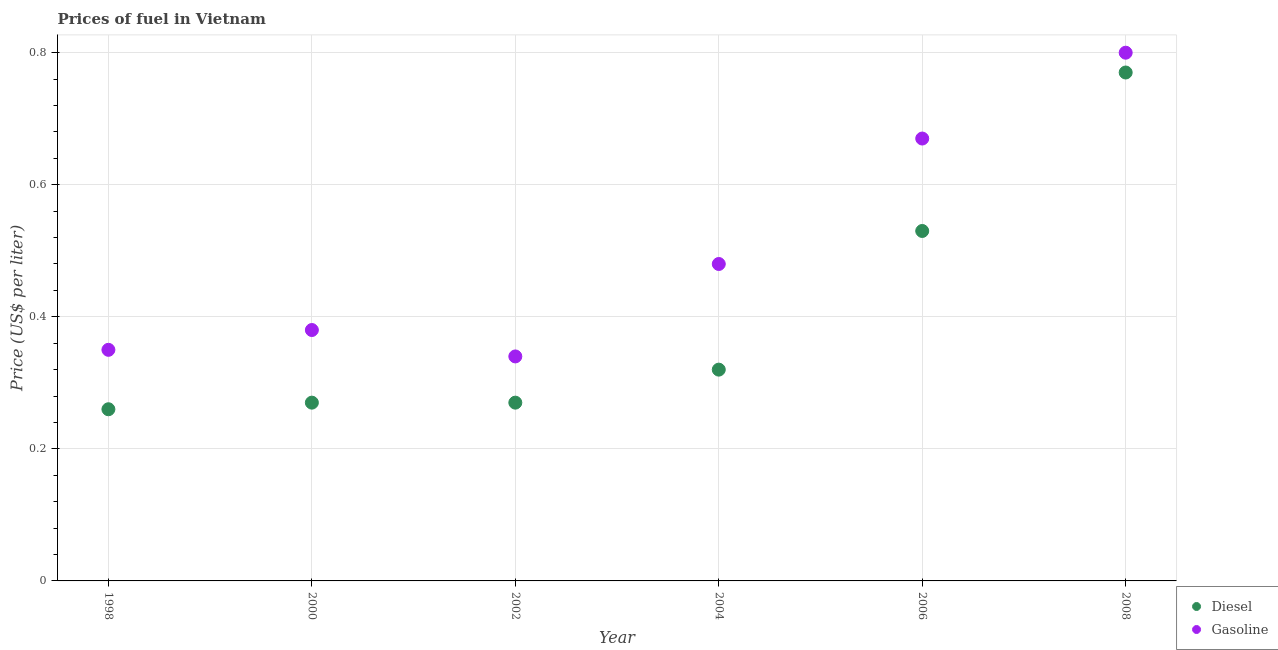Is the number of dotlines equal to the number of legend labels?
Your response must be concise. Yes. What is the diesel price in 2006?
Your answer should be compact. 0.53. Across all years, what is the maximum gasoline price?
Your answer should be compact. 0.8. Across all years, what is the minimum diesel price?
Provide a short and direct response. 0.26. In which year was the gasoline price maximum?
Give a very brief answer. 2008. In which year was the diesel price minimum?
Give a very brief answer. 1998. What is the total gasoline price in the graph?
Provide a short and direct response. 3.02. What is the difference between the gasoline price in 2000 and that in 2002?
Ensure brevity in your answer.  0.04. What is the difference between the gasoline price in 2004 and the diesel price in 2008?
Give a very brief answer. -0.29. What is the average gasoline price per year?
Offer a terse response. 0.5. In the year 2006, what is the difference between the diesel price and gasoline price?
Make the answer very short. -0.14. What is the ratio of the diesel price in 2002 to that in 2004?
Provide a short and direct response. 0.84. Is the difference between the diesel price in 2000 and 2008 greater than the difference between the gasoline price in 2000 and 2008?
Provide a short and direct response. No. What is the difference between the highest and the second highest gasoline price?
Make the answer very short. 0.13. What is the difference between the highest and the lowest gasoline price?
Provide a succinct answer. 0.46. Is the diesel price strictly greater than the gasoline price over the years?
Provide a succinct answer. No. Is the diesel price strictly less than the gasoline price over the years?
Give a very brief answer. Yes. How many dotlines are there?
Offer a terse response. 2. How many years are there in the graph?
Offer a terse response. 6. What is the difference between two consecutive major ticks on the Y-axis?
Your answer should be compact. 0.2. Does the graph contain grids?
Offer a very short reply. Yes. How are the legend labels stacked?
Your answer should be compact. Vertical. What is the title of the graph?
Provide a succinct answer. Prices of fuel in Vietnam. What is the label or title of the X-axis?
Your response must be concise. Year. What is the label or title of the Y-axis?
Give a very brief answer. Price (US$ per liter). What is the Price (US$ per liter) of Diesel in 1998?
Your answer should be very brief. 0.26. What is the Price (US$ per liter) in Gasoline in 1998?
Give a very brief answer. 0.35. What is the Price (US$ per liter) in Diesel in 2000?
Ensure brevity in your answer.  0.27. What is the Price (US$ per liter) of Gasoline in 2000?
Your answer should be compact. 0.38. What is the Price (US$ per liter) of Diesel in 2002?
Your response must be concise. 0.27. What is the Price (US$ per liter) of Gasoline in 2002?
Offer a terse response. 0.34. What is the Price (US$ per liter) in Diesel in 2004?
Ensure brevity in your answer.  0.32. What is the Price (US$ per liter) in Gasoline in 2004?
Ensure brevity in your answer.  0.48. What is the Price (US$ per liter) in Diesel in 2006?
Provide a succinct answer. 0.53. What is the Price (US$ per liter) in Gasoline in 2006?
Provide a short and direct response. 0.67. What is the Price (US$ per liter) in Diesel in 2008?
Offer a very short reply. 0.77. What is the Price (US$ per liter) of Gasoline in 2008?
Provide a short and direct response. 0.8. Across all years, what is the maximum Price (US$ per liter) in Diesel?
Your response must be concise. 0.77. Across all years, what is the maximum Price (US$ per liter) of Gasoline?
Your answer should be compact. 0.8. Across all years, what is the minimum Price (US$ per liter) of Diesel?
Your answer should be compact. 0.26. Across all years, what is the minimum Price (US$ per liter) of Gasoline?
Offer a very short reply. 0.34. What is the total Price (US$ per liter) in Diesel in the graph?
Ensure brevity in your answer.  2.42. What is the total Price (US$ per liter) of Gasoline in the graph?
Make the answer very short. 3.02. What is the difference between the Price (US$ per liter) in Diesel in 1998 and that in 2000?
Keep it short and to the point. -0.01. What is the difference between the Price (US$ per liter) in Gasoline in 1998 and that in 2000?
Keep it short and to the point. -0.03. What is the difference between the Price (US$ per liter) of Diesel in 1998 and that in 2002?
Your answer should be very brief. -0.01. What is the difference between the Price (US$ per liter) of Gasoline in 1998 and that in 2002?
Your answer should be very brief. 0.01. What is the difference between the Price (US$ per liter) in Diesel in 1998 and that in 2004?
Provide a succinct answer. -0.06. What is the difference between the Price (US$ per liter) of Gasoline in 1998 and that in 2004?
Your response must be concise. -0.13. What is the difference between the Price (US$ per liter) of Diesel in 1998 and that in 2006?
Your answer should be very brief. -0.27. What is the difference between the Price (US$ per liter) of Gasoline in 1998 and that in 2006?
Keep it short and to the point. -0.32. What is the difference between the Price (US$ per liter) in Diesel in 1998 and that in 2008?
Offer a terse response. -0.51. What is the difference between the Price (US$ per liter) of Gasoline in 1998 and that in 2008?
Provide a short and direct response. -0.45. What is the difference between the Price (US$ per liter) in Gasoline in 2000 and that in 2002?
Give a very brief answer. 0.04. What is the difference between the Price (US$ per liter) in Gasoline in 2000 and that in 2004?
Offer a terse response. -0.1. What is the difference between the Price (US$ per liter) of Diesel in 2000 and that in 2006?
Your answer should be very brief. -0.26. What is the difference between the Price (US$ per liter) of Gasoline in 2000 and that in 2006?
Ensure brevity in your answer.  -0.29. What is the difference between the Price (US$ per liter) of Diesel in 2000 and that in 2008?
Make the answer very short. -0.5. What is the difference between the Price (US$ per liter) in Gasoline in 2000 and that in 2008?
Your answer should be compact. -0.42. What is the difference between the Price (US$ per liter) of Diesel in 2002 and that in 2004?
Make the answer very short. -0.05. What is the difference between the Price (US$ per liter) of Gasoline in 2002 and that in 2004?
Ensure brevity in your answer.  -0.14. What is the difference between the Price (US$ per liter) in Diesel in 2002 and that in 2006?
Ensure brevity in your answer.  -0.26. What is the difference between the Price (US$ per liter) of Gasoline in 2002 and that in 2006?
Provide a succinct answer. -0.33. What is the difference between the Price (US$ per liter) of Diesel in 2002 and that in 2008?
Provide a succinct answer. -0.5. What is the difference between the Price (US$ per liter) of Gasoline in 2002 and that in 2008?
Keep it short and to the point. -0.46. What is the difference between the Price (US$ per liter) of Diesel in 2004 and that in 2006?
Make the answer very short. -0.21. What is the difference between the Price (US$ per liter) of Gasoline in 2004 and that in 2006?
Your response must be concise. -0.19. What is the difference between the Price (US$ per liter) in Diesel in 2004 and that in 2008?
Ensure brevity in your answer.  -0.45. What is the difference between the Price (US$ per liter) of Gasoline in 2004 and that in 2008?
Provide a short and direct response. -0.32. What is the difference between the Price (US$ per liter) in Diesel in 2006 and that in 2008?
Keep it short and to the point. -0.24. What is the difference between the Price (US$ per liter) of Gasoline in 2006 and that in 2008?
Your answer should be very brief. -0.13. What is the difference between the Price (US$ per liter) in Diesel in 1998 and the Price (US$ per liter) in Gasoline in 2000?
Provide a succinct answer. -0.12. What is the difference between the Price (US$ per liter) of Diesel in 1998 and the Price (US$ per liter) of Gasoline in 2002?
Keep it short and to the point. -0.08. What is the difference between the Price (US$ per liter) in Diesel in 1998 and the Price (US$ per liter) in Gasoline in 2004?
Make the answer very short. -0.22. What is the difference between the Price (US$ per liter) of Diesel in 1998 and the Price (US$ per liter) of Gasoline in 2006?
Your answer should be compact. -0.41. What is the difference between the Price (US$ per liter) in Diesel in 1998 and the Price (US$ per liter) in Gasoline in 2008?
Ensure brevity in your answer.  -0.54. What is the difference between the Price (US$ per liter) in Diesel in 2000 and the Price (US$ per liter) in Gasoline in 2002?
Your answer should be very brief. -0.07. What is the difference between the Price (US$ per liter) of Diesel in 2000 and the Price (US$ per liter) of Gasoline in 2004?
Provide a short and direct response. -0.21. What is the difference between the Price (US$ per liter) in Diesel in 2000 and the Price (US$ per liter) in Gasoline in 2006?
Provide a short and direct response. -0.4. What is the difference between the Price (US$ per liter) of Diesel in 2000 and the Price (US$ per liter) of Gasoline in 2008?
Provide a succinct answer. -0.53. What is the difference between the Price (US$ per liter) in Diesel in 2002 and the Price (US$ per liter) in Gasoline in 2004?
Provide a succinct answer. -0.21. What is the difference between the Price (US$ per liter) of Diesel in 2002 and the Price (US$ per liter) of Gasoline in 2008?
Your answer should be compact. -0.53. What is the difference between the Price (US$ per liter) of Diesel in 2004 and the Price (US$ per liter) of Gasoline in 2006?
Provide a succinct answer. -0.35. What is the difference between the Price (US$ per liter) in Diesel in 2004 and the Price (US$ per liter) in Gasoline in 2008?
Ensure brevity in your answer.  -0.48. What is the difference between the Price (US$ per liter) of Diesel in 2006 and the Price (US$ per liter) of Gasoline in 2008?
Your response must be concise. -0.27. What is the average Price (US$ per liter) in Diesel per year?
Give a very brief answer. 0.4. What is the average Price (US$ per liter) in Gasoline per year?
Offer a terse response. 0.5. In the year 1998, what is the difference between the Price (US$ per liter) in Diesel and Price (US$ per liter) in Gasoline?
Provide a succinct answer. -0.09. In the year 2000, what is the difference between the Price (US$ per liter) in Diesel and Price (US$ per liter) in Gasoline?
Provide a succinct answer. -0.11. In the year 2002, what is the difference between the Price (US$ per liter) of Diesel and Price (US$ per liter) of Gasoline?
Offer a very short reply. -0.07. In the year 2004, what is the difference between the Price (US$ per liter) in Diesel and Price (US$ per liter) in Gasoline?
Provide a succinct answer. -0.16. In the year 2006, what is the difference between the Price (US$ per liter) in Diesel and Price (US$ per liter) in Gasoline?
Offer a very short reply. -0.14. In the year 2008, what is the difference between the Price (US$ per liter) of Diesel and Price (US$ per liter) of Gasoline?
Provide a succinct answer. -0.03. What is the ratio of the Price (US$ per liter) in Diesel in 1998 to that in 2000?
Your answer should be compact. 0.96. What is the ratio of the Price (US$ per liter) in Gasoline in 1998 to that in 2000?
Provide a succinct answer. 0.92. What is the ratio of the Price (US$ per liter) in Gasoline in 1998 to that in 2002?
Ensure brevity in your answer.  1.03. What is the ratio of the Price (US$ per liter) of Diesel in 1998 to that in 2004?
Provide a succinct answer. 0.81. What is the ratio of the Price (US$ per liter) in Gasoline in 1998 to that in 2004?
Keep it short and to the point. 0.73. What is the ratio of the Price (US$ per liter) in Diesel in 1998 to that in 2006?
Offer a terse response. 0.49. What is the ratio of the Price (US$ per liter) of Gasoline in 1998 to that in 2006?
Make the answer very short. 0.52. What is the ratio of the Price (US$ per liter) of Diesel in 1998 to that in 2008?
Offer a terse response. 0.34. What is the ratio of the Price (US$ per liter) in Gasoline in 1998 to that in 2008?
Offer a terse response. 0.44. What is the ratio of the Price (US$ per liter) of Diesel in 2000 to that in 2002?
Your answer should be very brief. 1. What is the ratio of the Price (US$ per liter) in Gasoline in 2000 to that in 2002?
Your answer should be very brief. 1.12. What is the ratio of the Price (US$ per liter) in Diesel in 2000 to that in 2004?
Keep it short and to the point. 0.84. What is the ratio of the Price (US$ per liter) in Gasoline in 2000 to that in 2004?
Your response must be concise. 0.79. What is the ratio of the Price (US$ per liter) of Diesel in 2000 to that in 2006?
Ensure brevity in your answer.  0.51. What is the ratio of the Price (US$ per liter) of Gasoline in 2000 to that in 2006?
Offer a very short reply. 0.57. What is the ratio of the Price (US$ per liter) in Diesel in 2000 to that in 2008?
Give a very brief answer. 0.35. What is the ratio of the Price (US$ per liter) in Gasoline in 2000 to that in 2008?
Your response must be concise. 0.47. What is the ratio of the Price (US$ per liter) in Diesel in 2002 to that in 2004?
Ensure brevity in your answer.  0.84. What is the ratio of the Price (US$ per liter) in Gasoline in 2002 to that in 2004?
Give a very brief answer. 0.71. What is the ratio of the Price (US$ per liter) in Diesel in 2002 to that in 2006?
Offer a very short reply. 0.51. What is the ratio of the Price (US$ per liter) of Gasoline in 2002 to that in 2006?
Provide a succinct answer. 0.51. What is the ratio of the Price (US$ per liter) in Diesel in 2002 to that in 2008?
Offer a terse response. 0.35. What is the ratio of the Price (US$ per liter) of Gasoline in 2002 to that in 2008?
Offer a very short reply. 0.42. What is the ratio of the Price (US$ per liter) in Diesel in 2004 to that in 2006?
Offer a terse response. 0.6. What is the ratio of the Price (US$ per liter) in Gasoline in 2004 to that in 2006?
Provide a short and direct response. 0.72. What is the ratio of the Price (US$ per liter) of Diesel in 2004 to that in 2008?
Your answer should be very brief. 0.42. What is the ratio of the Price (US$ per liter) of Diesel in 2006 to that in 2008?
Offer a terse response. 0.69. What is the ratio of the Price (US$ per liter) in Gasoline in 2006 to that in 2008?
Make the answer very short. 0.84. What is the difference between the highest and the second highest Price (US$ per liter) of Diesel?
Give a very brief answer. 0.24. What is the difference between the highest and the second highest Price (US$ per liter) of Gasoline?
Keep it short and to the point. 0.13. What is the difference between the highest and the lowest Price (US$ per liter) of Diesel?
Give a very brief answer. 0.51. What is the difference between the highest and the lowest Price (US$ per liter) of Gasoline?
Make the answer very short. 0.46. 